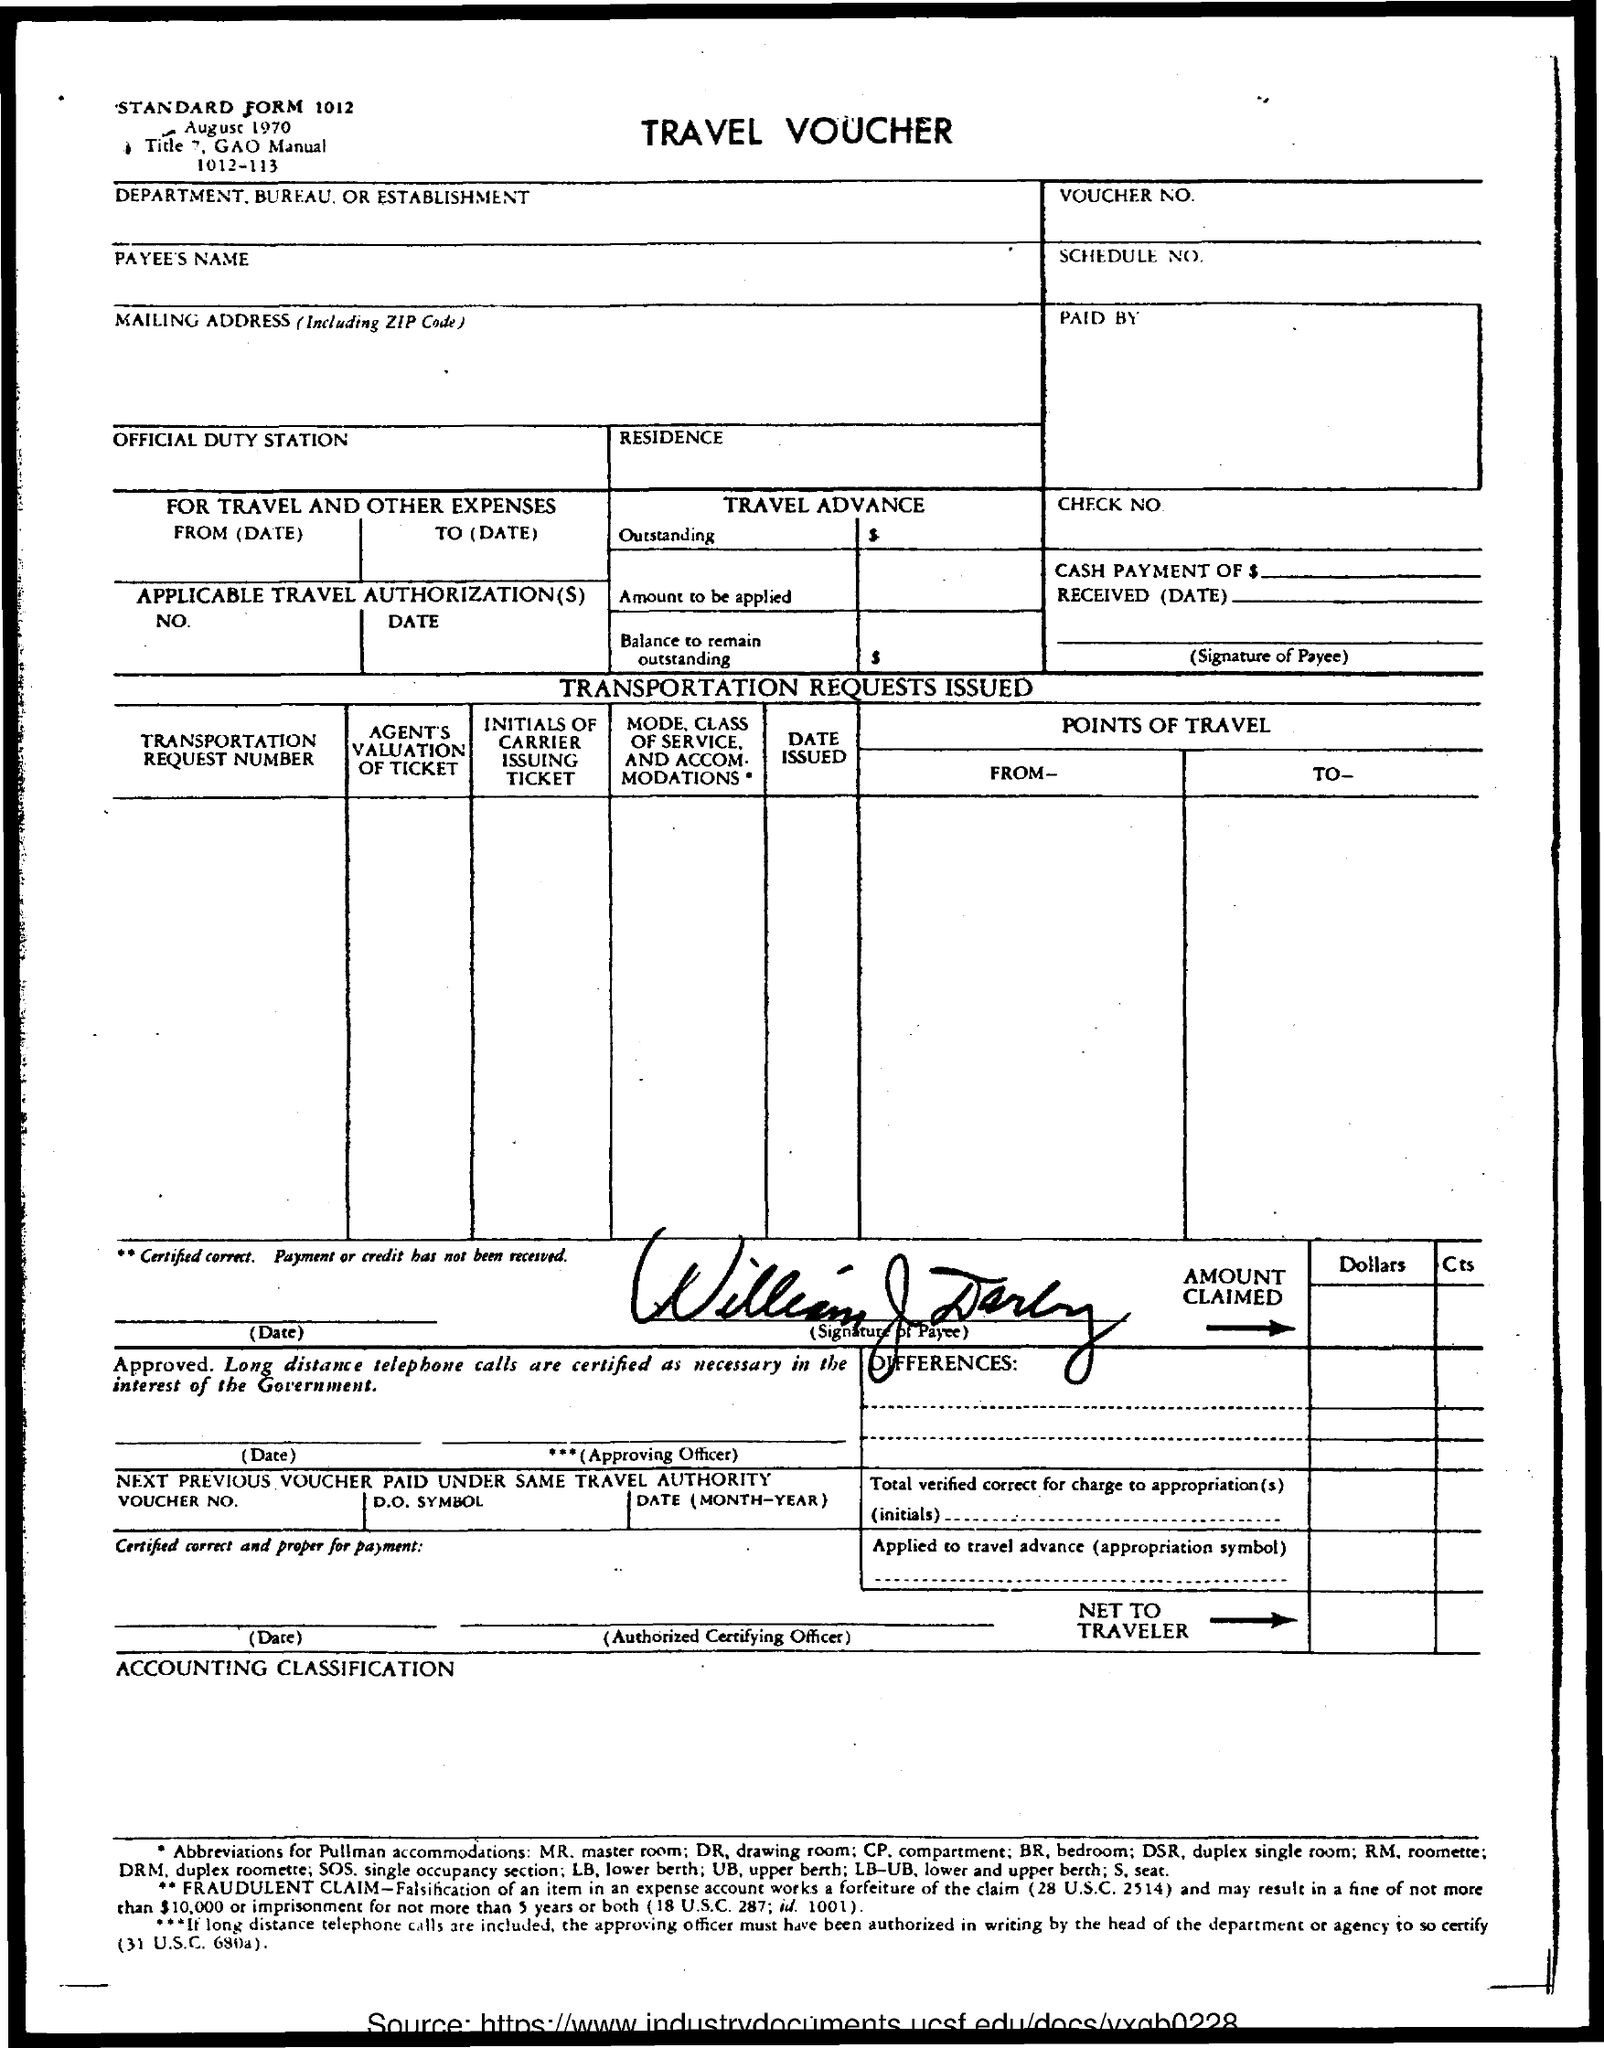Point out several critical features in this image. The document mentions the date of August 1970. 